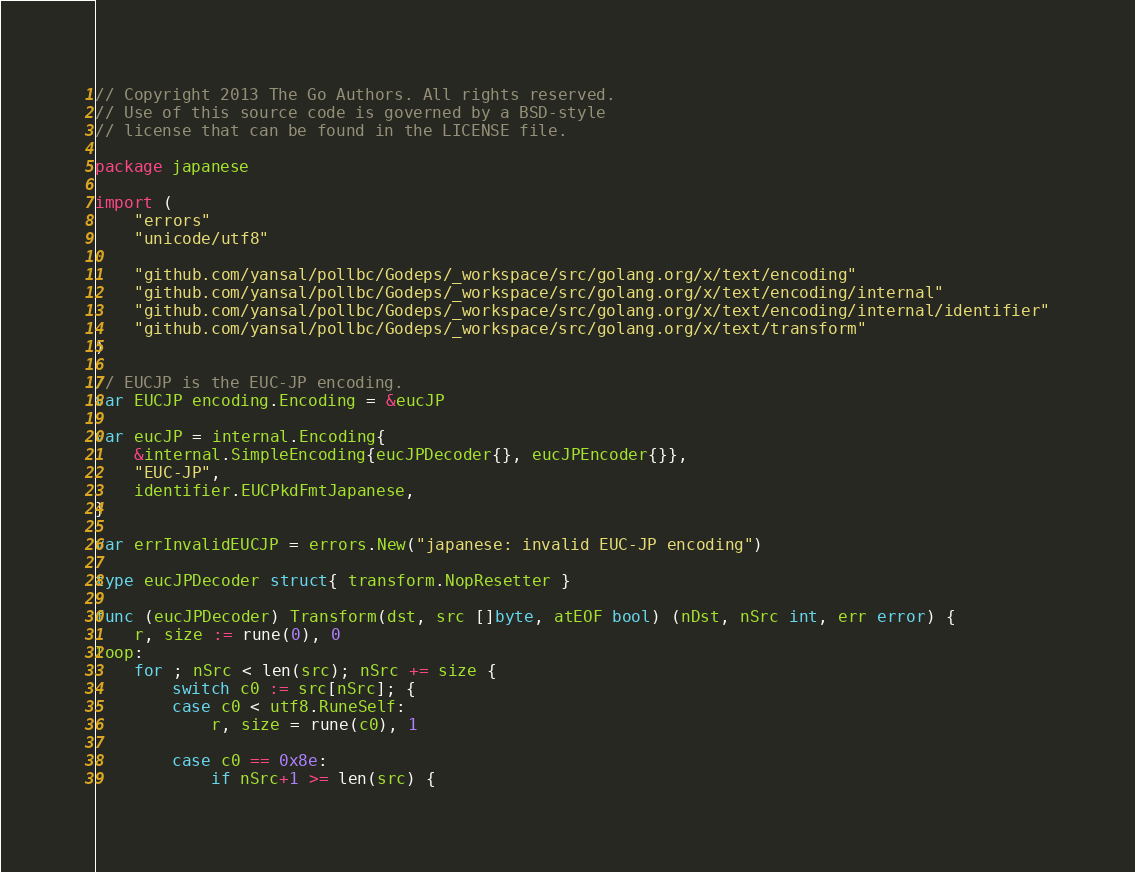<code> <loc_0><loc_0><loc_500><loc_500><_Go_>// Copyright 2013 The Go Authors. All rights reserved.
// Use of this source code is governed by a BSD-style
// license that can be found in the LICENSE file.

package japanese

import (
	"errors"
	"unicode/utf8"

	"github.com/yansal/pollbc/Godeps/_workspace/src/golang.org/x/text/encoding"
	"github.com/yansal/pollbc/Godeps/_workspace/src/golang.org/x/text/encoding/internal"
	"github.com/yansal/pollbc/Godeps/_workspace/src/golang.org/x/text/encoding/internal/identifier"
	"github.com/yansal/pollbc/Godeps/_workspace/src/golang.org/x/text/transform"
)

// EUCJP is the EUC-JP encoding.
var EUCJP encoding.Encoding = &eucJP

var eucJP = internal.Encoding{
	&internal.SimpleEncoding{eucJPDecoder{}, eucJPEncoder{}},
	"EUC-JP",
	identifier.EUCPkdFmtJapanese,
}

var errInvalidEUCJP = errors.New("japanese: invalid EUC-JP encoding")

type eucJPDecoder struct{ transform.NopResetter }

func (eucJPDecoder) Transform(dst, src []byte, atEOF bool) (nDst, nSrc int, err error) {
	r, size := rune(0), 0
loop:
	for ; nSrc < len(src); nSrc += size {
		switch c0 := src[nSrc]; {
		case c0 < utf8.RuneSelf:
			r, size = rune(c0), 1

		case c0 == 0x8e:
			if nSrc+1 >= len(src) {</code> 